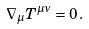Convert formula to latex. <formula><loc_0><loc_0><loc_500><loc_500>\nabla _ { \mu } T ^ { \mu \nu } = 0 \, .</formula> 